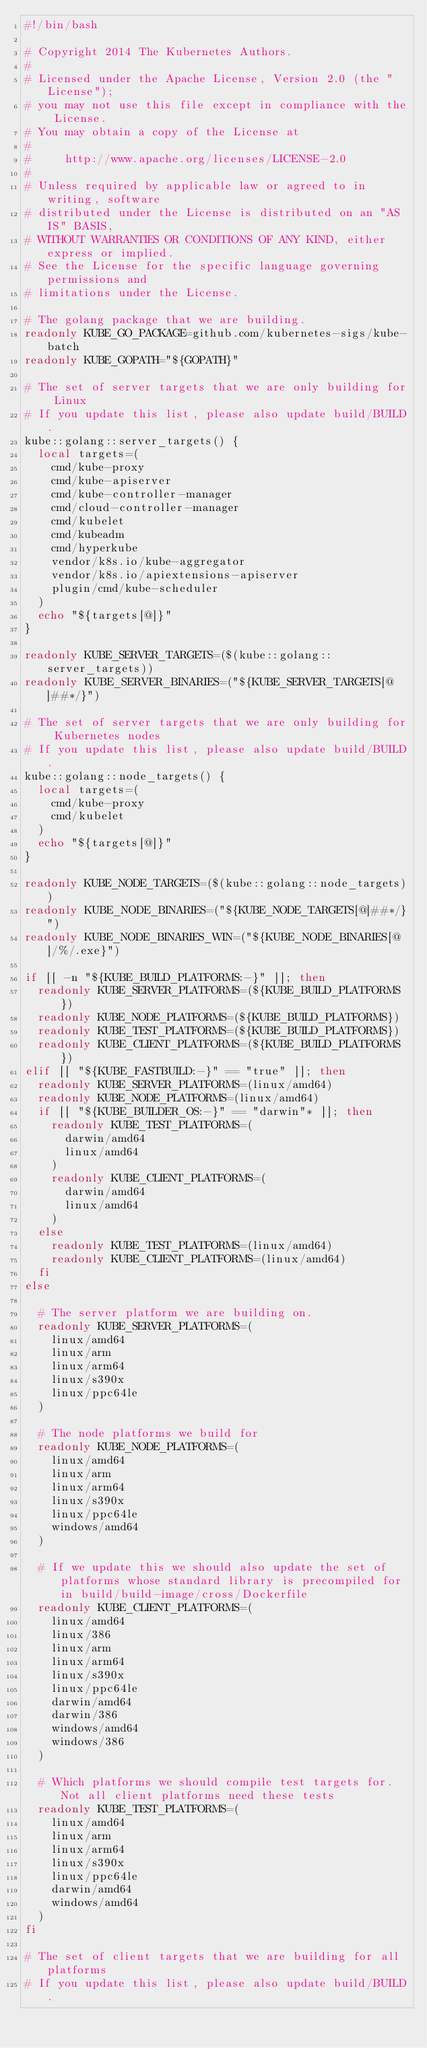Convert code to text. <code><loc_0><loc_0><loc_500><loc_500><_Bash_>#!/bin/bash

# Copyright 2014 The Kubernetes Authors.
#
# Licensed under the Apache License, Version 2.0 (the "License");
# you may not use this file except in compliance with the License.
# You may obtain a copy of the License at
#
#     http://www.apache.org/licenses/LICENSE-2.0
#
# Unless required by applicable law or agreed to in writing, software
# distributed under the License is distributed on an "AS IS" BASIS,
# WITHOUT WARRANTIES OR CONDITIONS OF ANY KIND, either express or implied.
# See the License for the specific language governing permissions and
# limitations under the License.

# The golang package that we are building.
readonly KUBE_GO_PACKAGE=github.com/kubernetes-sigs/kube-batch
readonly KUBE_GOPATH="${GOPATH}"

# The set of server targets that we are only building for Linux
# If you update this list, please also update build/BUILD.
kube::golang::server_targets() {
  local targets=(
    cmd/kube-proxy
    cmd/kube-apiserver
    cmd/kube-controller-manager
    cmd/cloud-controller-manager
    cmd/kubelet
    cmd/kubeadm
    cmd/hyperkube
    vendor/k8s.io/kube-aggregator
    vendor/k8s.io/apiextensions-apiserver
    plugin/cmd/kube-scheduler
  )
  echo "${targets[@]}"
}

readonly KUBE_SERVER_TARGETS=($(kube::golang::server_targets))
readonly KUBE_SERVER_BINARIES=("${KUBE_SERVER_TARGETS[@]##*/}")

# The set of server targets that we are only building for Kubernetes nodes
# If you update this list, please also update build/BUILD.
kube::golang::node_targets() {
  local targets=(
    cmd/kube-proxy
    cmd/kubelet
  )
  echo "${targets[@]}"
}

readonly KUBE_NODE_TARGETS=($(kube::golang::node_targets))
readonly KUBE_NODE_BINARIES=("${KUBE_NODE_TARGETS[@]##*/}")
readonly KUBE_NODE_BINARIES_WIN=("${KUBE_NODE_BINARIES[@]/%/.exe}")

if [[ -n "${KUBE_BUILD_PLATFORMS:-}" ]]; then
  readonly KUBE_SERVER_PLATFORMS=(${KUBE_BUILD_PLATFORMS})
  readonly KUBE_NODE_PLATFORMS=(${KUBE_BUILD_PLATFORMS})
  readonly KUBE_TEST_PLATFORMS=(${KUBE_BUILD_PLATFORMS})
  readonly KUBE_CLIENT_PLATFORMS=(${KUBE_BUILD_PLATFORMS})
elif [[ "${KUBE_FASTBUILD:-}" == "true" ]]; then
  readonly KUBE_SERVER_PLATFORMS=(linux/amd64)
  readonly KUBE_NODE_PLATFORMS=(linux/amd64)
  if [[ "${KUBE_BUILDER_OS:-}" == "darwin"* ]]; then
    readonly KUBE_TEST_PLATFORMS=(
      darwin/amd64
      linux/amd64
    )
    readonly KUBE_CLIENT_PLATFORMS=(
      darwin/amd64
      linux/amd64
    )
  else
    readonly KUBE_TEST_PLATFORMS=(linux/amd64)
    readonly KUBE_CLIENT_PLATFORMS=(linux/amd64)
  fi
else

  # The server platform we are building on.
  readonly KUBE_SERVER_PLATFORMS=(
    linux/amd64
    linux/arm
    linux/arm64
    linux/s390x
    linux/ppc64le
  )

  # The node platforms we build for
  readonly KUBE_NODE_PLATFORMS=(
    linux/amd64
    linux/arm
    linux/arm64
    linux/s390x
    linux/ppc64le
    windows/amd64
  )

  # If we update this we should also update the set of platforms whose standard library is precompiled for in build/build-image/cross/Dockerfile
  readonly KUBE_CLIENT_PLATFORMS=(
    linux/amd64
    linux/386
    linux/arm
    linux/arm64
    linux/s390x
    linux/ppc64le
    darwin/amd64
    darwin/386
    windows/amd64
    windows/386
  )

  # Which platforms we should compile test targets for. Not all client platforms need these tests
  readonly KUBE_TEST_PLATFORMS=(
    linux/amd64
    linux/arm
    linux/arm64
    linux/s390x
    linux/ppc64le
    darwin/amd64
    windows/amd64
  )
fi

# The set of client targets that we are building for all platforms
# If you update this list, please also update build/BUILD.</code> 